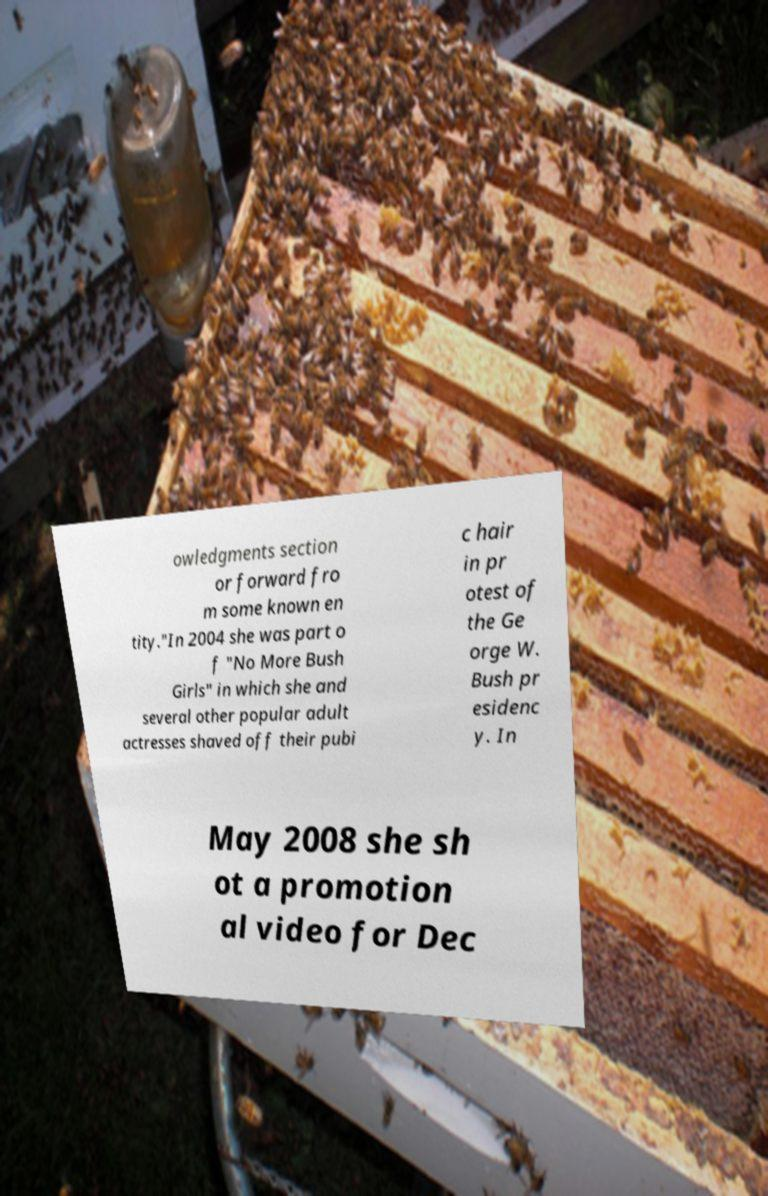Please read and relay the text visible in this image. What does it say? owledgments section or forward fro m some known en tity."In 2004 she was part o f "No More Bush Girls" in which she and several other popular adult actresses shaved off their pubi c hair in pr otest of the Ge orge W. Bush pr esidenc y. In May 2008 she sh ot a promotion al video for Dec 